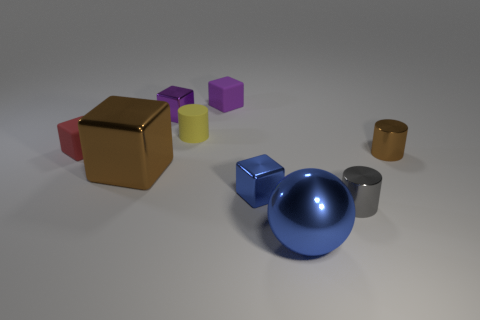What is the size of the metallic thing that is the same color as the big metal cube?
Offer a very short reply. Small. What is the size of the shiny thing that is both in front of the big shiny block and right of the blue shiny ball?
Offer a terse response. Small. There is a tiny cylinder behind the matte cube in front of the tiny shiny thing that is on the left side of the small blue block; what is it made of?
Provide a succinct answer. Rubber. What is the material of the thing that is the same color as the shiny sphere?
Make the answer very short. Metal. There is a small thing right of the gray metallic thing; is it the same color as the small shiny block that is to the right of the purple shiny cube?
Keep it short and to the point. No. The brown metal object that is to the right of the tiny cylinder that is in front of the blue metallic cube on the left side of the large blue thing is what shape?
Offer a terse response. Cylinder. There is a metallic object that is both behind the blue metallic cube and right of the tiny purple matte thing; what shape is it?
Keep it short and to the point. Cylinder. What number of tiny purple cubes are in front of the object on the right side of the cylinder that is in front of the tiny brown cylinder?
Your answer should be very brief. 0. What size is the brown metallic object that is the same shape as the small purple metallic thing?
Ensure brevity in your answer.  Large. Are there any other things that are the same size as the yellow object?
Make the answer very short. Yes. 